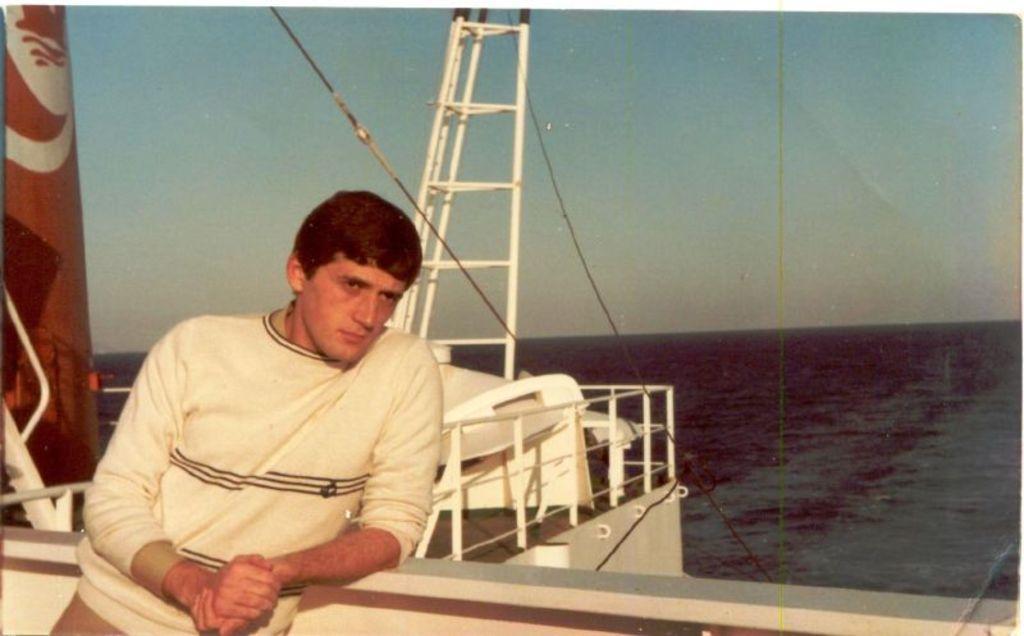Could you give a brief overview of what you see in this image? In the foreground of this image, there is a man standing and it seems like he is standing on a ship where we can see railing, few rod structures, ropes and an object on the left. In the background, there is water and the sky. 